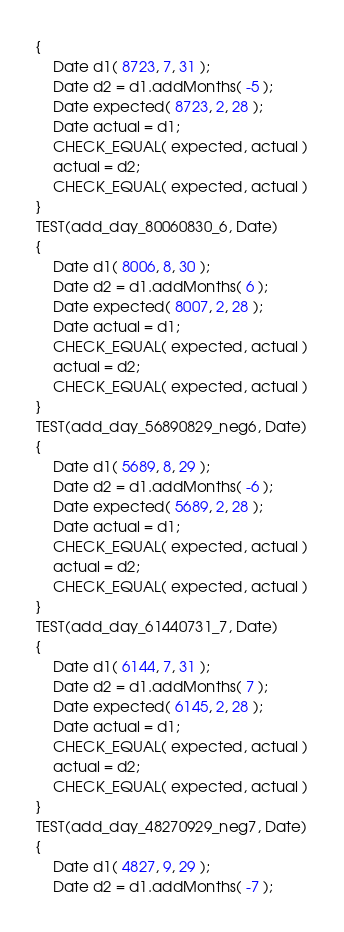<code> <loc_0><loc_0><loc_500><loc_500><_C++_>{
    Date d1( 8723, 7, 31 );
    Date d2 = d1.addMonths( -5 );
    Date expected( 8723, 2, 28 );
    Date actual = d1;
    CHECK_EQUAL( expected, actual )
	actual = d2;
	CHECK_EQUAL( expected, actual )
}
TEST(add_day_80060830_6, Date)
{
    Date d1( 8006, 8, 30 );
    Date d2 = d1.addMonths( 6 );
    Date expected( 8007, 2, 28 );
    Date actual = d1;
    CHECK_EQUAL( expected, actual )
	actual = d2;
	CHECK_EQUAL( expected, actual )
}
TEST(add_day_56890829_neg6, Date)
{
    Date d1( 5689, 8, 29 );
    Date d2 = d1.addMonths( -6 );
    Date expected( 5689, 2, 28 );
    Date actual = d1;
    CHECK_EQUAL( expected, actual )
	actual = d2;
	CHECK_EQUAL( expected, actual )
}
TEST(add_day_61440731_7, Date)
{
    Date d1( 6144, 7, 31 );
    Date d2 = d1.addMonths( 7 );
    Date expected( 6145, 2, 28 );
    Date actual = d1;
    CHECK_EQUAL( expected, actual )
	actual = d2;
	CHECK_EQUAL( expected, actual )
}
TEST(add_day_48270929_neg7, Date)
{
    Date d1( 4827, 9, 29 );
    Date d2 = d1.addMonths( -7 );</code> 